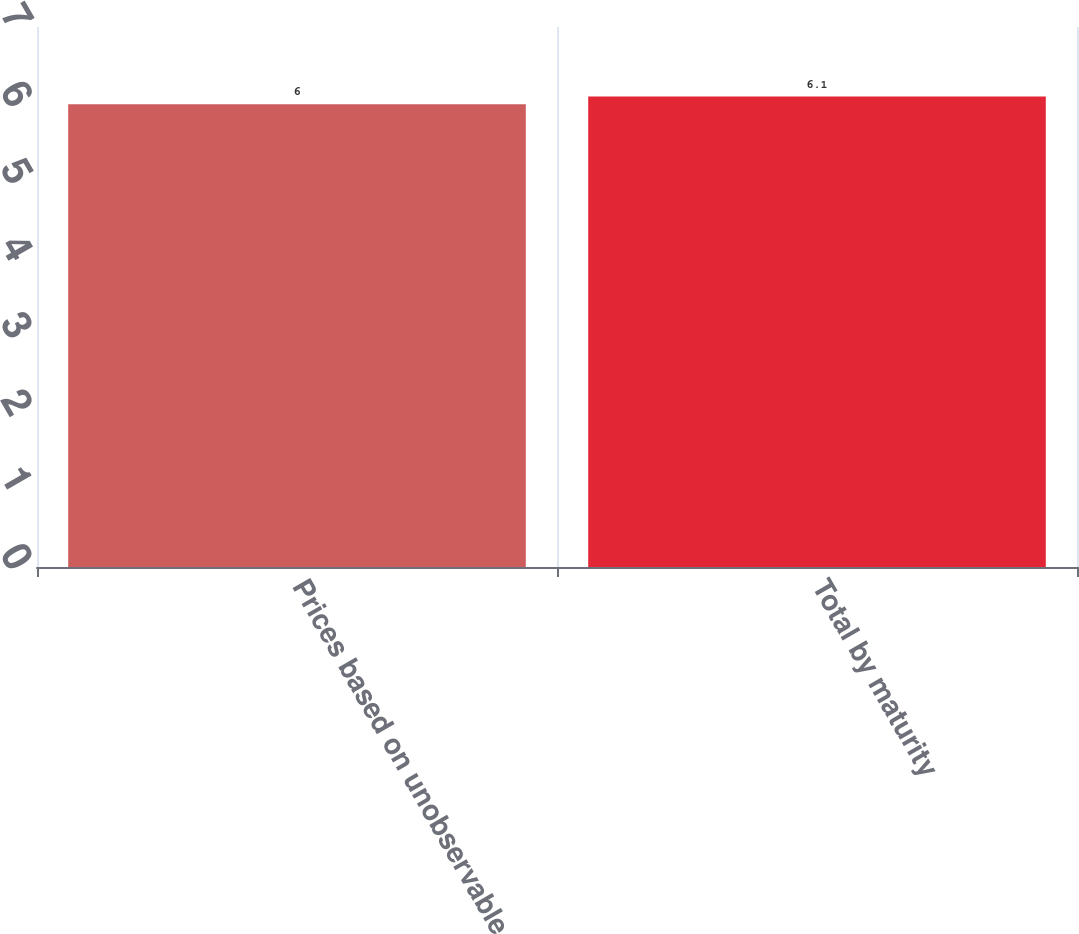<chart> <loc_0><loc_0><loc_500><loc_500><bar_chart><fcel>Prices based on unobservable<fcel>Total by maturity<nl><fcel>6<fcel>6.1<nl></chart> 